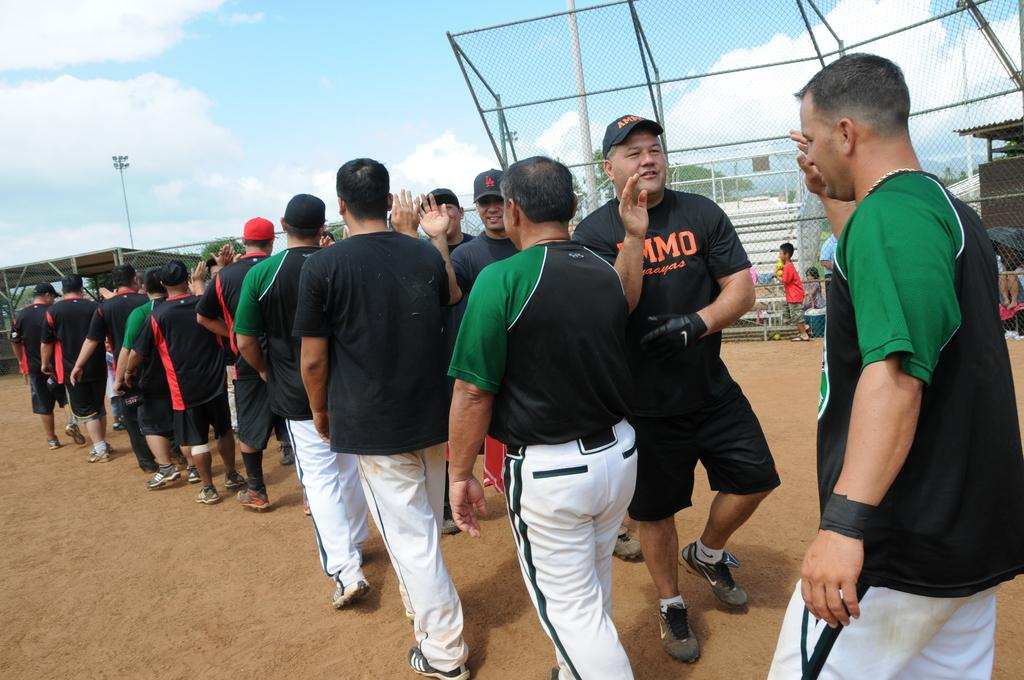<image>
Relay a brief, clear account of the picture shown. Two teams high five after a game, including a man in a LA baseball hat. 